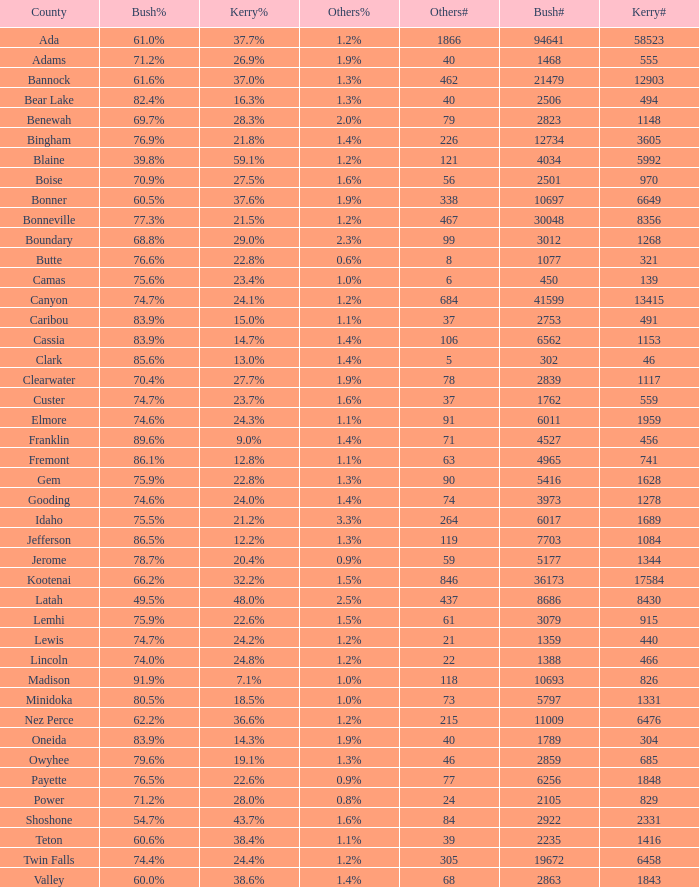How many different counts of the votes for Bush are there in the county where he got 69.7% of the votes? 1.0. 